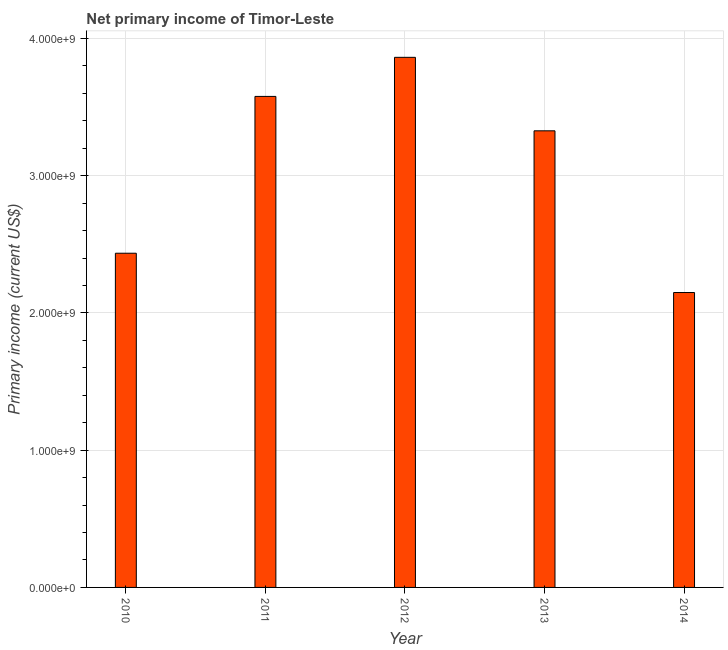Does the graph contain grids?
Make the answer very short. Yes. What is the title of the graph?
Make the answer very short. Net primary income of Timor-Leste. What is the label or title of the Y-axis?
Provide a succinct answer. Primary income (current US$). What is the amount of primary income in 2013?
Your response must be concise. 3.33e+09. Across all years, what is the maximum amount of primary income?
Provide a short and direct response. 3.86e+09. Across all years, what is the minimum amount of primary income?
Make the answer very short. 2.15e+09. What is the sum of the amount of primary income?
Make the answer very short. 1.53e+1. What is the difference between the amount of primary income in 2013 and 2014?
Give a very brief answer. 1.18e+09. What is the average amount of primary income per year?
Provide a short and direct response. 3.07e+09. What is the median amount of primary income?
Your answer should be compact. 3.33e+09. What is the ratio of the amount of primary income in 2011 to that in 2012?
Your answer should be very brief. 0.93. Is the amount of primary income in 2010 less than that in 2013?
Offer a terse response. Yes. What is the difference between the highest and the second highest amount of primary income?
Your response must be concise. 2.85e+08. Is the sum of the amount of primary income in 2011 and 2013 greater than the maximum amount of primary income across all years?
Provide a short and direct response. Yes. What is the difference between the highest and the lowest amount of primary income?
Your answer should be compact. 1.71e+09. How many bars are there?
Your answer should be very brief. 5. Are all the bars in the graph horizontal?
Provide a succinct answer. No. How many years are there in the graph?
Provide a succinct answer. 5. What is the difference between two consecutive major ticks on the Y-axis?
Your answer should be compact. 1.00e+09. Are the values on the major ticks of Y-axis written in scientific E-notation?
Keep it short and to the point. Yes. What is the Primary income (current US$) of 2010?
Your answer should be compact. 2.43e+09. What is the Primary income (current US$) in 2011?
Ensure brevity in your answer.  3.58e+09. What is the Primary income (current US$) in 2012?
Your response must be concise. 3.86e+09. What is the Primary income (current US$) in 2013?
Ensure brevity in your answer.  3.33e+09. What is the Primary income (current US$) of 2014?
Make the answer very short. 2.15e+09. What is the difference between the Primary income (current US$) in 2010 and 2011?
Provide a short and direct response. -1.14e+09. What is the difference between the Primary income (current US$) in 2010 and 2012?
Offer a terse response. -1.43e+09. What is the difference between the Primary income (current US$) in 2010 and 2013?
Provide a short and direct response. -8.92e+08. What is the difference between the Primary income (current US$) in 2010 and 2014?
Give a very brief answer. 2.86e+08. What is the difference between the Primary income (current US$) in 2011 and 2012?
Offer a terse response. -2.85e+08. What is the difference between the Primary income (current US$) in 2011 and 2013?
Provide a short and direct response. 2.51e+08. What is the difference between the Primary income (current US$) in 2011 and 2014?
Provide a succinct answer. 1.43e+09. What is the difference between the Primary income (current US$) in 2012 and 2013?
Provide a succinct answer. 5.35e+08. What is the difference between the Primary income (current US$) in 2012 and 2014?
Make the answer very short. 1.71e+09. What is the difference between the Primary income (current US$) in 2013 and 2014?
Give a very brief answer. 1.18e+09. What is the ratio of the Primary income (current US$) in 2010 to that in 2011?
Your answer should be compact. 0.68. What is the ratio of the Primary income (current US$) in 2010 to that in 2012?
Ensure brevity in your answer.  0.63. What is the ratio of the Primary income (current US$) in 2010 to that in 2013?
Offer a terse response. 0.73. What is the ratio of the Primary income (current US$) in 2010 to that in 2014?
Your answer should be compact. 1.13. What is the ratio of the Primary income (current US$) in 2011 to that in 2012?
Offer a very short reply. 0.93. What is the ratio of the Primary income (current US$) in 2011 to that in 2013?
Provide a succinct answer. 1.07. What is the ratio of the Primary income (current US$) in 2011 to that in 2014?
Give a very brief answer. 1.67. What is the ratio of the Primary income (current US$) in 2012 to that in 2013?
Ensure brevity in your answer.  1.16. What is the ratio of the Primary income (current US$) in 2012 to that in 2014?
Ensure brevity in your answer.  1.8. What is the ratio of the Primary income (current US$) in 2013 to that in 2014?
Ensure brevity in your answer.  1.55. 